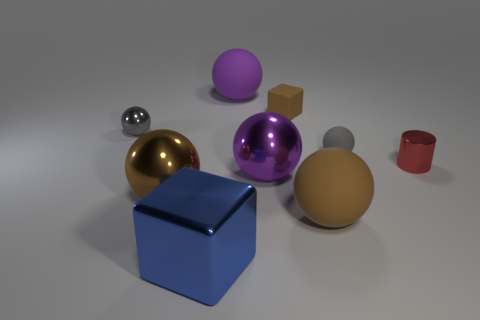Subtract 2 balls. How many balls are left? 4 Subtract all brown balls. How many balls are left? 4 Subtract all gray rubber balls. How many balls are left? 5 Subtract all red spheres. Subtract all gray cylinders. How many spheres are left? 6 Add 1 blocks. How many objects exist? 10 Subtract all balls. How many objects are left? 3 Add 3 large yellow matte cubes. How many large yellow matte cubes exist? 3 Subtract 1 blue cubes. How many objects are left? 8 Subtract all red shiny cylinders. Subtract all tiny brown shiny balls. How many objects are left? 8 Add 9 large brown metallic objects. How many large brown metallic objects are left? 10 